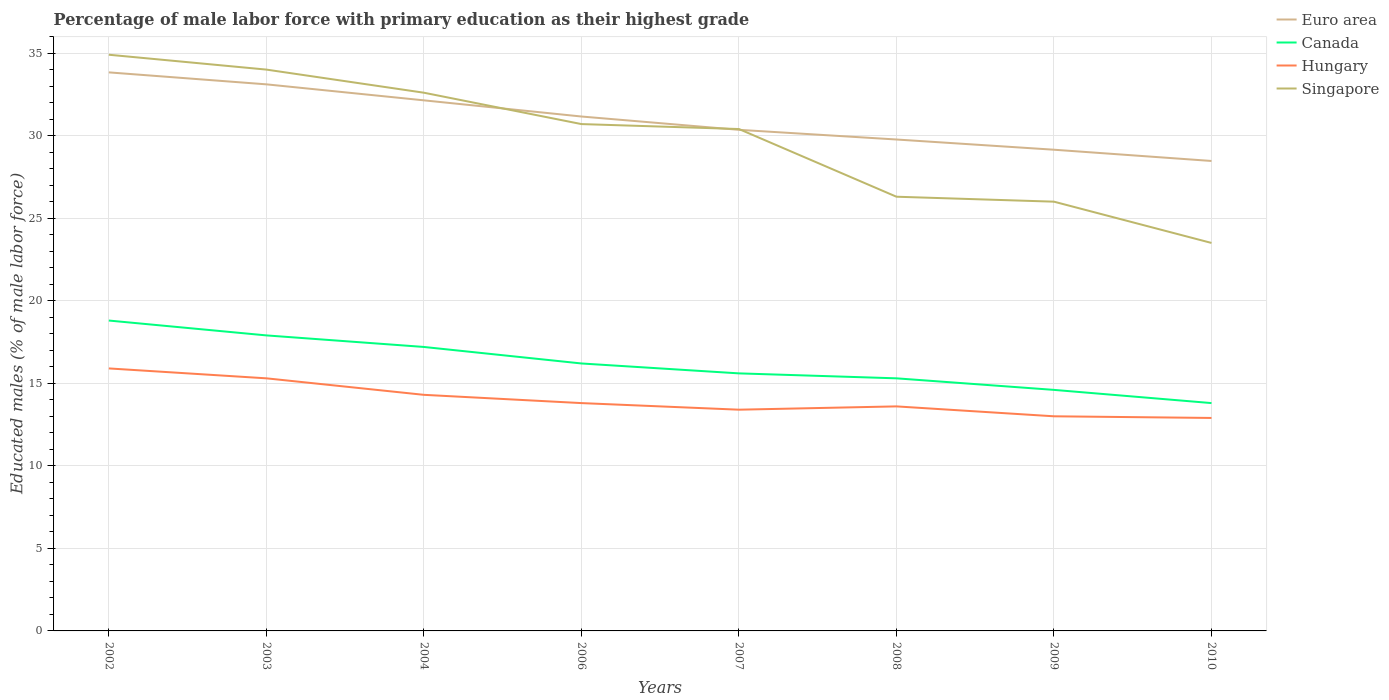Across all years, what is the maximum percentage of male labor force with primary education in Euro area?
Keep it short and to the point. 28.47. What is the total percentage of male labor force with primary education in Singapore in the graph?
Provide a succinct answer. 7.7. What is the difference between the highest and the second highest percentage of male labor force with primary education in Euro area?
Your answer should be compact. 5.37. Is the percentage of male labor force with primary education in Singapore strictly greater than the percentage of male labor force with primary education in Euro area over the years?
Offer a very short reply. No. How many lines are there?
Ensure brevity in your answer.  4. How many years are there in the graph?
Your answer should be compact. 8. What is the difference between two consecutive major ticks on the Y-axis?
Provide a short and direct response. 5. Does the graph contain any zero values?
Provide a short and direct response. No. Does the graph contain grids?
Your answer should be very brief. Yes. Where does the legend appear in the graph?
Offer a terse response. Top right. What is the title of the graph?
Your answer should be very brief. Percentage of male labor force with primary education as their highest grade. What is the label or title of the X-axis?
Provide a short and direct response. Years. What is the label or title of the Y-axis?
Provide a short and direct response. Educated males (% of male labor force). What is the Educated males (% of male labor force) of Euro area in 2002?
Provide a short and direct response. 33.83. What is the Educated males (% of male labor force) in Canada in 2002?
Your answer should be compact. 18.8. What is the Educated males (% of male labor force) in Hungary in 2002?
Make the answer very short. 15.9. What is the Educated males (% of male labor force) of Singapore in 2002?
Provide a short and direct response. 34.9. What is the Educated males (% of male labor force) of Euro area in 2003?
Make the answer very short. 33.11. What is the Educated males (% of male labor force) of Canada in 2003?
Ensure brevity in your answer.  17.9. What is the Educated males (% of male labor force) in Hungary in 2003?
Make the answer very short. 15.3. What is the Educated males (% of male labor force) in Singapore in 2003?
Ensure brevity in your answer.  34. What is the Educated males (% of male labor force) of Euro area in 2004?
Offer a very short reply. 32.14. What is the Educated males (% of male labor force) of Canada in 2004?
Provide a short and direct response. 17.2. What is the Educated males (% of male labor force) in Hungary in 2004?
Provide a short and direct response. 14.3. What is the Educated males (% of male labor force) of Singapore in 2004?
Ensure brevity in your answer.  32.6. What is the Educated males (% of male labor force) in Euro area in 2006?
Provide a succinct answer. 31.16. What is the Educated males (% of male labor force) in Canada in 2006?
Ensure brevity in your answer.  16.2. What is the Educated males (% of male labor force) in Hungary in 2006?
Your answer should be very brief. 13.8. What is the Educated males (% of male labor force) in Singapore in 2006?
Provide a short and direct response. 30.7. What is the Educated males (% of male labor force) of Euro area in 2007?
Provide a succinct answer. 30.35. What is the Educated males (% of male labor force) in Canada in 2007?
Offer a terse response. 15.6. What is the Educated males (% of male labor force) of Hungary in 2007?
Your answer should be compact. 13.4. What is the Educated males (% of male labor force) in Singapore in 2007?
Give a very brief answer. 30.4. What is the Educated males (% of male labor force) of Euro area in 2008?
Provide a short and direct response. 29.77. What is the Educated males (% of male labor force) of Canada in 2008?
Offer a very short reply. 15.3. What is the Educated males (% of male labor force) of Hungary in 2008?
Provide a short and direct response. 13.6. What is the Educated males (% of male labor force) of Singapore in 2008?
Ensure brevity in your answer.  26.3. What is the Educated males (% of male labor force) in Euro area in 2009?
Offer a terse response. 29.15. What is the Educated males (% of male labor force) in Canada in 2009?
Your response must be concise. 14.6. What is the Educated males (% of male labor force) of Hungary in 2009?
Make the answer very short. 13. What is the Educated males (% of male labor force) of Euro area in 2010?
Provide a short and direct response. 28.47. What is the Educated males (% of male labor force) in Canada in 2010?
Keep it short and to the point. 13.8. What is the Educated males (% of male labor force) of Hungary in 2010?
Your answer should be compact. 12.9. Across all years, what is the maximum Educated males (% of male labor force) of Euro area?
Keep it short and to the point. 33.83. Across all years, what is the maximum Educated males (% of male labor force) in Canada?
Ensure brevity in your answer.  18.8. Across all years, what is the maximum Educated males (% of male labor force) of Hungary?
Make the answer very short. 15.9. Across all years, what is the maximum Educated males (% of male labor force) of Singapore?
Keep it short and to the point. 34.9. Across all years, what is the minimum Educated males (% of male labor force) of Euro area?
Give a very brief answer. 28.47. Across all years, what is the minimum Educated males (% of male labor force) of Canada?
Keep it short and to the point. 13.8. Across all years, what is the minimum Educated males (% of male labor force) in Hungary?
Your answer should be compact. 12.9. Across all years, what is the minimum Educated males (% of male labor force) in Singapore?
Offer a terse response. 23.5. What is the total Educated males (% of male labor force) of Euro area in the graph?
Give a very brief answer. 247.96. What is the total Educated males (% of male labor force) of Canada in the graph?
Provide a short and direct response. 129.4. What is the total Educated males (% of male labor force) of Hungary in the graph?
Your response must be concise. 112.2. What is the total Educated males (% of male labor force) in Singapore in the graph?
Provide a succinct answer. 238.4. What is the difference between the Educated males (% of male labor force) of Euro area in 2002 and that in 2003?
Offer a very short reply. 0.72. What is the difference between the Educated males (% of male labor force) of Hungary in 2002 and that in 2003?
Make the answer very short. 0.6. What is the difference between the Educated males (% of male labor force) of Singapore in 2002 and that in 2003?
Make the answer very short. 0.9. What is the difference between the Educated males (% of male labor force) of Euro area in 2002 and that in 2004?
Ensure brevity in your answer.  1.69. What is the difference between the Educated males (% of male labor force) of Hungary in 2002 and that in 2004?
Your response must be concise. 1.6. What is the difference between the Educated males (% of male labor force) in Singapore in 2002 and that in 2004?
Your answer should be very brief. 2.3. What is the difference between the Educated males (% of male labor force) of Euro area in 2002 and that in 2006?
Your answer should be compact. 2.67. What is the difference between the Educated males (% of male labor force) in Canada in 2002 and that in 2006?
Your answer should be compact. 2.6. What is the difference between the Educated males (% of male labor force) of Hungary in 2002 and that in 2006?
Keep it short and to the point. 2.1. What is the difference between the Educated males (% of male labor force) of Euro area in 2002 and that in 2007?
Keep it short and to the point. 3.48. What is the difference between the Educated males (% of male labor force) of Hungary in 2002 and that in 2007?
Your answer should be compact. 2.5. What is the difference between the Educated males (% of male labor force) of Euro area in 2002 and that in 2008?
Keep it short and to the point. 4.07. What is the difference between the Educated males (% of male labor force) in Canada in 2002 and that in 2008?
Provide a succinct answer. 3.5. What is the difference between the Educated males (% of male labor force) in Hungary in 2002 and that in 2008?
Your response must be concise. 2.3. What is the difference between the Educated males (% of male labor force) of Euro area in 2002 and that in 2009?
Ensure brevity in your answer.  4.68. What is the difference between the Educated males (% of male labor force) of Canada in 2002 and that in 2009?
Offer a very short reply. 4.2. What is the difference between the Educated males (% of male labor force) of Singapore in 2002 and that in 2009?
Make the answer very short. 8.9. What is the difference between the Educated males (% of male labor force) of Euro area in 2002 and that in 2010?
Make the answer very short. 5.37. What is the difference between the Educated males (% of male labor force) of Hungary in 2002 and that in 2010?
Make the answer very short. 3. What is the difference between the Educated males (% of male labor force) in Singapore in 2002 and that in 2010?
Your answer should be compact. 11.4. What is the difference between the Educated males (% of male labor force) in Singapore in 2003 and that in 2004?
Provide a short and direct response. 1.4. What is the difference between the Educated males (% of male labor force) in Euro area in 2003 and that in 2006?
Your answer should be compact. 1.95. What is the difference between the Educated males (% of male labor force) in Singapore in 2003 and that in 2006?
Offer a terse response. 3.3. What is the difference between the Educated males (% of male labor force) of Euro area in 2003 and that in 2007?
Provide a succinct answer. 2.75. What is the difference between the Educated males (% of male labor force) in Canada in 2003 and that in 2007?
Keep it short and to the point. 2.3. What is the difference between the Educated males (% of male labor force) of Hungary in 2003 and that in 2007?
Offer a terse response. 1.9. What is the difference between the Educated males (% of male labor force) of Euro area in 2003 and that in 2008?
Keep it short and to the point. 3.34. What is the difference between the Educated males (% of male labor force) in Canada in 2003 and that in 2008?
Offer a very short reply. 2.6. What is the difference between the Educated males (% of male labor force) of Singapore in 2003 and that in 2008?
Offer a terse response. 7.7. What is the difference between the Educated males (% of male labor force) of Euro area in 2003 and that in 2009?
Provide a short and direct response. 3.96. What is the difference between the Educated males (% of male labor force) in Canada in 2003 and that in 2009?
Offer a terse response. 3.3. What is the difference between the Educated males (% of male labor force) of Hungary in 2003 and that in 2009?
Your response must be concise. 2.3. What is the difference between the Educated males (% of male labor force) of Euro area in 2003 and that in 2010?
Your answer should be very brief. 4.64. What is the difference between the Educated males (% of male labor force) in Canada in 2003 and that in 2010?
Give a very brief answer. 4.1. What is the difference between the Educated males (% of male labor force) in Hungary in 2003 and that in 2010?
Keep it short and to the point. 2.4. What is the difference between the Educated males (% of male labor force) in Euro area in 2004 and that in 2006?
Your response must be concise. 0.98. What is the difference between the Educated males (% of male labor force) in Canada in 2004 and that in 2006?
Keep it short and to the point. 1. What is the difference between the Educated males (% of male labor force) of Hungary in 2004 and that in 2006?
Your response must be concise. 0.5. What is the difference between the Educated males (% of male labor force) of Euro area in 2004 and that in 2007?
Provide a succinct answer. 1.79. What is the difference between the Educated males (% of male labor force) in Euro area in 2004 and that in 2008?
Provide a short and direct response. 2.37. What is the difference between the Educated males (% of male labor force) in Canada in 2004 and that in 2008?
Your response must be concise. 1.9. What is the difference between the Educated males (% of male labor force) of Singapore in 2004 and that in 2008?
Your response must be concise. 6.3. What is the difference between the Educated males (% of male labor force) of Euro area in 2004 and that in 2009?
Give a very brief answer. 2.99. What is the difference between the Educated males (% of male labor force) of Singapore in 2004 and that in 2009?
Your answer should be very brief. 6.6. What is the difference between the Educated males (% of male labor force) of Euro area in 2004 and that in 2010?
Give a very brief answer. 3.67. What is the difference between the Educated males (% of male labor force) of Canada in 2004 and that in 2010?
Provide a succinct answer. 3.4. What is the difference between the Educated males (% of male labor force) in Hungary in 2004 and that in 2010?
Provide a succinct answer. 1.4. What is the difference between the Educated males (% of male labor force) in Singapore in 2004 and that in 2010?
Keep it short and to the point. 9.1. What is the difference between the Educated males (% of male labor force) in Euro area in 2006 and that in 2007?
Offer a terse response. 0.81. What is the difference between the Educated males (% of male labor force) in Canada in 2006 and that in 2007?
Your answer should be compact. 0.6. What is the difference between the Educated males (% of male labor force) of Singapore in 2006 and that in 2007?
Offer a very short reply. 0.3. What is the difference between the Educated males (% of male labor force) of Euro area in 2006 and that in 2008?
Offer a terse response. 1.39. What is the difference between the Educated males (% of male labor force) in Hungary in 2006 and that in 2008?
Your answer should be very brief. 0.2. What is the difference between the Educated males (% of male labor force) in Singapore in 2006 and that in 2008?
Keep it short and to the point. 4.4. What is the difference between the Educated males (% of male labor force) of Euro area in 2006 and that in 2009?
Keep it short and to the point. 2.01. What is the difference between the Educated males (% of male labor force) of Hungary in 2006 and that in 2009?
Give a very brief answer. 0.8. What is the difference between the Educated males (% of male labor force) of Singapore in 2006 and that in 2009?
Your answer should be very brief. 4.7. What is the difference between the Educated males (% of male labor force) in Euro area in 2006 and that in 2010?
Keep it short and to the point. 2.69. What is the difference between the Educated males (% of male labor force) of Canada in 2006 and that in 2010?
Provide a short and direct response. 2.4. What is the difference between the Educated males (% of male labor force) of Euro area in 2007 and that in 2008?
Keep it short and to the point. 0.59. What is the difference between the Educated males (% of male labor force) in Canada in 2007 and that in 2008?
Give a very brief answer. 0.3. What is the difference between the Educated males (% of male labor force) in Hungary in 2007 and that in 2008?
Make the answer very short. -0.2. What is the difference between the Educated males (% of male labor force) of Singapore in 2007 and that in 2008?
Make the answer very short. 4.1. What is the difference between the Educated males (% of male labor force) in Euro area in 2007 and that in 2009?
Provide a succinct answer. 1.21. What is the difference between the Educated males (% of male labor force) in Canada in 2007 and that in 2009?
Provide a succinct answer. 1. What is the difference between the Educated males (% of male labor force) in Hungary in 2007 and that in 2009?
Your answer should be very brief. 0.4. What is the difference between the Educated males (% of male labor force) in Singapore in 2007 and that in 2009?
Offer a terse response. 4.4. What is the difference between the Educated males (% of male labor force) in Euro area in 2007 and that in 2010?
Your answer should be very brief. 1.89. What is the difference between the Educated males (% of male labor force) of Canada in 2007 and that in 2010?
Your response must be concise. 1.8. What is the difference between the Educated males (% of male labor force) of Hungary in 2007 and that in 2010?
Your answer should be very brief. 0.5. What is the difference between the Educated males (% of male labor force) in Singapore in 2007 and that in 2010?
Keep it short and to the point. 6.9. What is the difference between the Educated males (% of male labor force) in Euro area in 2008 and that in 2009?
Your answer should be compact. 0.62. What is the difference between the Educated males (% of male labor force) of Euro area in 2008 and that in 2010?
Keep it short and to the point. 1.3. What is the difference between the Educated males (% of male labor force) in Canada in 2008 and that in 2010?
Make the answer very short. 1.5. What is the difference between the Educated males (% of male labor force) in Euro area in 2009 and that in 2010?
Your answer should be compact. 0.68. What is the difference between the Educated males (% of male labor force) of Euro area in 2002 and the Educated males (% of male labor force) of Canada in 2003?
Make the answer very short. 15.93. What is the difference between the Educated males (% of male labor force) in Euro area in 2002 and the Educated males (% of male labor force) in Hungary in 2003?
Ensure brevity in your answer.  18.53. What is the difference between the Educated males (% of male labor force) of Euro area in 2002 and the Educated males (% of male labor force) of Singapore in 2003?
Offer a very short reply. -0.17. What is the difference between the Educated males (% of male labor force) in Canada in 2002 and the Educated males (% of male labor force) in Hungary in 2003?
Your response must be concise. 3.5. What is the difference between the Educated males (% of male labor force) in Canada in 2002 and the Educated males (% of male labor force) in Singapore in 2003?
Make the answer very short. -15.2. What is the difference between the Educated males (% of male labor force) in Hungary in 2002 and the Educated males (% of male labor force) in Singapore in 2003?
Your answer should be compact. -18.1. What is the difference between the Educated males (% of male labor force) of Euro area in 2002 and the Educated males (% of male labor force) of Canada in 2004?
Ensure brevity in your answer.  16.63. What is the difference between the Educated males (% of male labor force) of Euro area in 2002 and the Educated males (% of male labor force) of Hungary in 2004?
Your response must be concise. 19.53. What is the difference between the Educated males (% of male labor force) of Euro area in 2002 and the Educated males (% of male labor force) of Singapore in 2004?
Give a very brief answer. 1.23. What is the difference between the Educated males (% of male labor force) of Canada in 2002 and the Educated males (% of male labor force) of Hungary in 2004?
Your answer should be compact. 4.5. What is the difference between the Educated males (% of male labor force) of Canada in 2002 and the Educated males (% of male labor force) of Singapore in 2004?
Make the answer very short. -13.8. What is the difference between the Educated males (% of male labor force) of Hungary in 2002 and the Educated males (% of male labor force) of Singapore in 2004?
Keep it short and to the point. -16.7. What is the difference between the Educated males (% of male labor force) in Euro area in 2002 and the Educated males (% of male labor force) in Canada in 2006?
Offer a terse response. 17.63. What is the difference between the Educated males (% of male labor force) of Euro area in 2002 and the Educated males (% of male labor force) of Hungary in 2006?
Your answer should be compact. 20.03. What is the difference between the Educated males (% of male labor force) of Euro area in 2002 and the Educated males (% of male labor force) of Singapore in 2006?
Provide a short and direct response. 3.13. What is the difference between the Educated males (% of male labor force) in Hungary in 2002 and the Educated males (% of male labor force) in Singapore in 2006?
Offer a terse response. -14.8. What is the difference between the Educated males (% of male labor force) in Euro area in 2002 and the Educated males (% of male labor force) in Canada in 2007?
Make the answer very short. 18.23. What is the difference between the Educated males (% of male labor force) in Euro area in 2002 and the Educated males (% of male labor force) in Hungary in 2007?
Offer a terse response. 20.43. What is the difference between the Educated males (% of male labor force) of Euro area in 2002 and the Educated males (% of male labor force) of Singapore in 2007?
Ensure brevity in your answer.  3.43. What is the difference between the Educated males (% of male labor force) in Canada in 2002 and the Educated males (% of male labor force) in Singapore in 2007?
Your answer should be very brief. -11.6. What is the difference between the Educated males (% of male labor force) in Hungary in 2002 and the Educated males (% of male labor force) in Singapore in 2007?
Your answer should be compact. -14.5. What is the difference between the Educated males (% of male labor force) of Euro area in 2002 and the Educated males (% of male labor force) of Canada in 2008?
Your answer should be very brief. 18.53. What is the difference between the Educated males (% of male labor force) of Euro area in 2002 and the Educated males (% of male labor force) of Hungary in 2008?
Give a very brief answer. 20.23. What is the difference between the Educated males (% of male labor force) of Euro area in 2002 and the Educated males (% of male labor force) of Singapore in 2008?
Your answer should be very brief. 7.53. What is the difference between the Educated males (% of male labor force) of Canada in 2002 and the Educated males (% of male labor force) of Hungary in 2008?
Offer a very short reply. 5.2. What is the difference between the Educated males (% of male labor force) of Euro area in 2002 and the Educated males (% of male labor force) of Canada in 2009?
Your answer should be very brief. 19.23. What is the difference between the Educated males (% of male labor force) in Euro area in 2002 and the Educated males (% of male labor force) in Hungary in 2009?
Your response must be concise. 20.83. What is the difference between the Educated males (% of male labor force) of Euro area in 2002 and the Educated males (% of male labor force) of Singapore in 2009?
Your answer should be very brief. 7.83. What is the difference between the Educated males (% of male labor force) of Canada in 2002 and the Educated males (% of male labor force) of Singapore in 2009?
Your response must be concise. -7.2. What is the difference between the Educated males (% of male labor force) of Hungary in 2002 and the Educated males (% of male labor force) of Singapore in 2009?
Give a very brief answer. -10.1. What is the difference between the Educated males (% of male labor force) in Euro area in 2002 and the Educated males (% of male labor force) in Canada in 2010?
Provide a succinct answer. 20.03. What is the difference between the Educated males (% of male labor force) of Euro area in 2002 and the Educated males (% of male labor force) of Hungary in 2010?
Ensure brevity in your answer.  20.93. What is the difference between the Educated males (% of male labor force) in Euro area in 2002 and the Educated males (% of male labor force) in Singapore in 2010?
Keep it short and to the point. 10.33. What is the difference between the Educated males (% of male labor force) of Canada in 2002 and the Educated males (% of male labor force) of Singapore in 2010?
Your answer should be compact. -4.7. What is the difference between the Educated males (% of male labor force) in Euro area in 2003 and the Educated males (% of male labor force) in Canada in 2004?
Give a very brief answer. 15.91. What is the difference between the Educated males (% of male labor force) in Euro area in 2003 and the Educated males (% of male labor force) in Hungary in 2004?
Your response must be concise. 18.81. What is the difference between the Educated males (% of male labor force) in Euro area in 2003 and the Educated males (% of male labor force) in Singapore in 2004?
Make the answer very short. 0.51. What is the difference between the Educated males (% of male labor force) of Canada in 2003 and the Educated males (% of male labor force) of Singapore in 2004?
Keep it short and to the point. -14.7. What is the difference between the Educated males (% of male labor force) in Hungary in 2003 and the Educated males (% of male labor force) in Singapore in 2004?
Ensure brevity in your answer.  -17.3. What is the difference between the Educated males (% of male labor force) of Euro area in 2003 and the Educated males (% of male labor force) of Canada in 2006?
Offer a very short reply. 16.91. What is the difference between the Educated males (% of male labor force) in Euro area in 2003 and the Educated males (% of male labor force) in Hungary in 2006?
Your answer should be compact. 19.31. What is the difference between the Educated males (% of male labor force) of Euro area in 2003 and the Educated males (% of male labor force) of Singapore in 2006?
Give a very brief answer. 2.41. What is the difference between the Educated males (% of male labor force) in Canada in 2003 and the Educated males (% of male labor force) in Singapore in 2006?
Give a very brief answer. -12.8. What is the difference between the Educated males (% of male labor force) in Hungary in 2003 and the Educated males (% of male labor force) in Singapore in 2006?
Make the answer very short. -15.4. What is the difference between the Educated males (% of male labor force) in Euro area in 2003 and the Educated males (% of male labor force) in Canada in 2007?
Your response must be concise. 17.51. What is the difference between the Educated males (% of male labor force) of Euro area in 2003 and the Educated males (% of male labor force) of Hungary in 2007?
Keep it short and to the point. 19.71. What is the difference between the Educated males (% of male labor force) of Euro area in 2003 and the Educated males (% of male labor force) of Singapore in 2007?
Your response must be concise. 2.71. What is the difference between the Educated males (% of male labor force) in Canada in 2003 and the Educated males (% of male labor force) in Hungary in 2007?
Your response must be concise. 4.5. What is the difference between the Educated males (% of male labor force) in Canada in 2003 and the Educated males (% of male labor force) in Singapore in 2007?
Ensure brevity in your answer.  -12.5. What is the difference between the Educated males (% of male labor force) in Hungary in 2003 and the Educated males (% of male labor force) in Singapore in 2007?
Your answer should be very brief. -15.1. What is the difference between the Educated males (% of male labor force) in Euro area in 2003 and the Educated males (% of male labor force) in Canada in 2008?
Give a very brief answer. 17.81. What is the difference between the Educated males (% of male labor force) in Euro area in 2003 and the Educated males (% of male labor force) in Hungary in 2008?
Your answer should be very brief. 19.51. What is the difference between the Educated males (% of male labor force) of Euro area in 2003 and the Educated males (% of male labor force) of Singapore in 2008?
Offer a very short reply. 6.81. What is the difference between the Educated males (% of male labor force) of Canada in 2003 and the Educated males (% of male labor force) of Hungary in 2008?
Ensure brevity in your answer.  4.3. What is the difference between the Educated males (% of male labor force) in Canada in 2003 and the Educated males (% of male labor force) in Singapore in 2008?
Your answer should be very brief. -8.4. What is the difference between the Educated males (% of male labor force) of Euro area in 2003 and the Educated males (% of male labor force) of Canada in 2009?
Your answer should be compact. 18.51. What is the difference between the Educated males (% of male labor force) of Euro area in 2003 and the Educated males (% of male labor force) of Hungary in 2009?
Provide a short and direct response. 20.11. What is the difference between the Educated males (% of male labor force) of Euro area in 2003 and the Educated males (% of male labor force) of Singapore in 2009?
Keep it short and to the point. 7.11. What is the difference between the Educated males (% of male labor force) of Canada in 2003 and the Educated males (% of male labor force) of Hungary in 2009?
Keep it short and to the point. 4.9. What is the difference between the Educated males (% of male labor force) of Canada in 2003 and the Educated males (% of male labor force) of Singapore in 2009?
Ensure brevity in your answer.  -8.1. What is the difference between the Educated males (% of male labor force) of Hungary in 2003 and the Educated males (% of male labor force) of Singapore in 2009?
Your response must be concise. -10.7. What is the difference between the Educated males (% of male labor force) of Euro area in 2003 and the Educated males (% of male labor force) of Canada in 2010?
Keep it short and to the point. 19.31. What is the difference between the Educated males (% of male labor force) of Euro area in 2003 and the Educated males (% of male labor force) of Hungary in 2010?
Keep it short and to the point. 20.21. What is the difference between the Educated males (% of male labor force) of Euro area in 2003 and the Educated males (% of male labor force) of Singapore in 2010?
Make the answer very short. 9.61. What is the difference between the Educated males (% of male labor force) of Canada in 2003 and the Educated males (% of male labor force) of Hungary in 2010?
Offer a very short reply. 5. What is the difference between the Educated males (% of male labor force) in Canada in 2003 and the Educated males (% of male labor force) in Singapore in 2010?
Make the answer very short. -5.6. What is the difference between the Educated males (% of male labor force) in Euro area in 2004 and the Educated males (% of male labor force) in Canada in 2006?
Provide a succinct answer. 15.94. What is the difference between the Educated males (% of male labor force) in Euro area in 2004 and the Educated males (% of male labor force) in Hungary in 2006?
Make the answer very short. 18.34. What is the difference between the Educated males (% of male labor force) in Euro area in 2004 and the Educated males (% of male labor force) in Singapore in 2006?
Your response must be concise. 1.44. What is the difference between the Educated males (% of male labor force) of Canada in 2004 and the Educated males (% of male labor force) of Hungary in 2006?
Make the answer very short. 3.4. What is the difference between the Educated males (% of male labor force) of Canada in 2004 and the Educated males (% of male labor force) of Singapore in 2006?
Your answer should be very brief. -13.5. What is the difference between the Educated males (% of male labor force) in Hungary in 2004 and the Educated males (% of male labor force) in Singapore in 2006?
Provide a succinct answer. -16.4. What is the difference between the Educated males (% of male labor force) in Euro area in 2004 and the Educated males (% of male labor force) in Canada in 2007?
Keep it short and to the point. 16.54. What is the difference between the Educated males (% of male labor force) in Euro area in 2004 and the Educated males (% of male labor force) in Hungary in 2007?
Keep it short and to the point. 18.74. What is the difference between the Educated males (% of male labor force) in Euro area in 2004 and the Educated males (% of male labor force) in Singapore in 2007?
Keep it short and to the point. 1.74. What is the difference between the Educated males (% of male labor force) in Canada in 2004 and the Educated males (% of male labor force) in Hungary in 2007?
Provide a short and direct response. 3.8. What is the difference between the Educated males (% of male labor force) of Canada in 2004 and the Educated males (% of male labor force) of Singapore in 2007?
Provide a succinct answer. -13.2. What is the difference between the Educated males (% of male labor force) in Hungary in 2004 and the Educated males (% of male labor force) in Singapore in 2007?
Your answer should be very brief. -16.1. What is the difference between the Educated males (% of male labor force) in Euro area in 2004 and the Educated males (% of male labor force) in Canada in 2008?
Make the answer very short. 16.84. What is the difference between the Educated males (% of male labor force) in Euro area in 2004 and the Educated males (% of male labor force) in Hungary in 2008?
Keep it short and to the point. 18.54. What is the difference between the Educated males (% of male labor force) of Euro area in 2004 and the Educated males (% of male labor force) of Singapore in 2008?
Ensure brevity in your answer.  5.84. What is the difference between the Educated males (% of male labor force) of Canada in 2004 and the Educated males (% of male labor force) of Hungary in 2008?
Your response must be concise. 3.6. What is the difference between the Educated males (% of male labor force) of Hungary in 2004 and the Educated males (% of male labor force) of Singapore in 2008?
Offer a very short reply. -12. What is the difference between the Educated males (% of male labor force) in Euro area in 2004 and the Educated males (% of male labor force) in Canada in 2009?
Offer a terse response. 17.54. What is the difference between the Educated males (% of male labor force) of Euro area in 2004 and the Educated males (% of male labor force) of Hungary in 2009?
Your response must be concise. 19.14. What is the difference between the Educated males (% of male labor force) of Euro area in 2004 and the Educated males (% of male labor force) of Singapore in 2009?
Your answer should be very brief. 6.14. What is the difference between the Educated males (% of male labor force) of Canada in 2004 and the Educated males (% of male labor force) of Singapore in 2009?
Keep it short and to the point. -8.8. What is the difference between the Educated males (% of male labor force) of Euro area in 2004 and the Educated males (% of male labor force) of Canada in 2010?
Offer a terse response. 18.34. What is the difference between the Educated males (% of male labor force) in Euro area in 2004 and the Educated males (% of male labor force) in Hungary in 2010?
Your response must be concise. 19.24. What is the difference between the Educated males (% of male labor force) in Euro area in 2004 and the Educated males (% of male labor force) in Singapore in 2010?
Keep it short and to the point. 8.64. What is the difference between the Educated males (% of male labor force) in Hungary in 2004 and the Educated males (% of male labor force) in Singapore in 2010?
Your answer should be very brief. -9.2. What is the difference between the Educated males (% of male labor force) in Euro area in 2006 and the Educated males (% of male labor force) in Canada in 2007?
Keep it short and to the point. 15.56. What is the difference between the Educated males (% of male labor force) of Euro area in 2006 and the Educated males (% of male labor force) of Hungary in 2007?
Your answer should be very brief. 17.76. What is the difference between the Educated males (% of male labor force) of Euro area in 2006 and the Educated males (% of male labor force) of Singapore in 2007?
Offer a terse response. 0.76. What is the difference between the Educated males (% of male labor force) in Canada in 2006 and the Educated males (% of male labor force) in Hungary in 2007?
Provide a succinct answer. 2.8. What is the difference between the Educated males (% of male labor force) in Hungary in 2006 and the Educated males (% of male labor force) in Singapore in 2007?
Give a very brief answer. -16.6. What is the difference between the Educated males (% of male labor force) in Euro area in 2006 and the Educated males (% of male labor force) in Canada in 2008?
Provide a short and direct response. 15.86. What is the difference between the Educated males (% of male labor force) in Euro area in 2006 and the Educated males (% of male labor force) in Hungary in 2008?
Offer a very short reply. 17.56. What is the difference between the Educated males (% of male labor force) of Euro area in 2006 and the Educated males (% of male labor force) of Singapore in 2008?
Your answer should be compact. 4.86. What is the difference between the Educated males (% of male labor force) of Canada in 2006 and the Educated males (% of male labor force) of Hungary in 2008?
Your answer should be very brief. 2.6. What is the difference between the Educated males (% of male labor force) in Canada in 2006 and the Educated males (% of male labor force) in Singapore in 2008?
Make the answer very short. -10.1. What is the difference between the Educated males (% of male labor force) of Euro area in 2006 and the Educated males (% of male labor force) of Canada in 2009?
Your answer should be very brief. 16.56. What is the difference between the Educated males (% of male labor force) of Euro area in 2006 and the Educated males (% of male labor force) of Hungary in 2009?
Offer a terse response. 18.16. What is the difference between the Educated males (% of male labor force) of Euro area in 2006 and the Educated males (% of male labor force) of Singapore in 2009?
Provide a succinct answer. 5.16. What is the difference between the Educated males (% of male labor force) in Canada in 2006 and the Educated males (% of male labor force) in Hungary in 2009?
Ensure brevity in your answer.  3.2. What is the difference between the Educated males (% of male labor force) in Canada in 2006 and the Educated males (% of male labor force) in Singapore in 2009?
Make the answer very short. -9.8. What is the difference between the Educated males (% of male labor force) of Euro area in 2006 and the Educated males (% of male labor force) of Canada in 2010?
Your answer should be very brief. 17.36. What is the difference between the Educated males (% of male labor force) of Euro area in 2006 and the Educated males (% of male labor force) of Hungary in 2010?
Provide a succinct answer. 18.26. What is the difference between the Educated males (% of male labor force) in Euro area in 2006 and the Educated males (% of male labor force) in Singapore in 2010?
Make the answer very short. 7.66. What is the difference between the Educated males (% of male labor force) in Canada in 2006 and the Educated males (% of male labor force) in Hungary in 2010?
Provide a succinct answer. 3.3. What is the difference between the Educated males (% of male labor force) of Canada in 2006 and the Educated males (% of male labor force) of Singapore in 2010?
Provide a short and direct response. -7.3. What is the difference between the Educated males (% of male labor force) of Hungary in 2006 and the Educated males (% of male labor force) of Singapore in 2010?
Keep it short and to the point. -9.7. What is the difference between the Educated males (% of male labor force) in Euro area in 2007 and the Educated males (% of male labor force) in Canada in 2008?
Ensure brevity in your answer.  15.05. What is the difference between the Educated males (% of male labor force) of Euro area in 2007 and the Educated males (% of male labor force) of Hungary in 2008?
Ensure brevity in your answer.  16.75. What is the difference between the Educated males (% of male labor force) of Euro area in 2007 and the Educated males (% of male labor force) of Singapore in 2008?
Your answer should be compact. 4.05. What is the difference between the Educated males (% of male labor force) of Canada in 2007 and the Educated males (% of male labor force) of Hungary in 2008?
Provide a short and direct response. 2. What is the difference between the Educated males (% of male labor force) in Canada in 2007 and the Educated males (% of male labor force) in Singapore in 2008?
Ensure brevity in your answer.  -10.7. What is the difference between the Educated males (% of male labor force) in Hungary in 2007 and the Educated males (% of male labor force) in Singapore in 2008?
Keep it short and to the point. -12.9. What is the difference between the Educated males (% of male labor force) in Euro area in 2007 and the Educated males (% of male labor force) in Canada in 2009?
Your answer should be very brief. 15.75. What is the difference between the Educated males (% of male labor force) of Euro area in 2007 and the Educated males (% of male labor force) of Hungary in 2009?
Keep it short and to the point. 17.35. What is the difference between the Educated males (% of male labor force) in Euro area in 2007 and the Educated males (% of male labor force) in Singapore in 2009?
Provide a succinct answer. 4.35. What is the difference between the Educated males (% of male labor force) of Euro area in 2007 and the Educated males (% of male labor force) of Canada in 2010?
Provide a succinct answer. 16.55. What is the difference between the Educated males (% of male labor force) of Euro area in 2007 and the Educated males (% of male labor force) of Hungary in 2010?
Provide a succinct answer. 17.45. What is the difference between the Educated males (% of male labor force) of Euro area in 2007 and the Educated males (% of male labor force) of Singapore in 2010?
Ensure brevity in your answer.  6.85. What is the difference between the Educated males (% of male labor force) in Canada in 2007 and the Educated males (% of male labor force) in Hungary in 2010?
Your response must be concise. 2.7. What is the difference between the Educated males (% of male labor force) of Hungary in 2007 and the Educated males (% of male labor force) of Singapore in 2010?
Offer a terse response. -10.1. What is the difference between the Educated males (% of male labor force) in Euro area in 2008 and the Educated males (% of male labor force) in Canada in 2009?
Ensure brevity in your answer.  15.17. What is the difference between the Educated males (% of male labor force) of Euro area in 2008 and the Educated males (% of male labor force) of Hungary in 2009?
Ensure brevity in your answer.  16.77. What is the difference between the Educated males (% of male labor force) of Euro area in 2008 and the Educated males (% of male labor force) of Singapore in 2009?
Ensure brevity in your answer.  3.77. What is the difference between the Educated males (% of male labor force) in Euro area in 2008 and the Educated males (% of male labor force) in Canada in 2010?
Offer a terse response. 15.97. What is the difference between the Educated males (% of male labor force) of Euro area in 2008 and the Educated males (% of male labor force) of Hungary in 2010?
Provide a short and direct response. 16.87. What is the difference between the Educated males (% of male labor force) in Euro area in 2008 and the Educated males (% of male labor force) in Singapore in 2010?
Make the answer very short. 6.27. What is the difference between the Educated males (% of male labor force) of Canada in 2008 and the Educated males (% of male labor force) of Hungary in 2010?
Offer a terse response. 2.4. What is the difference between the Educated males (% of male labor force) in Euro area in 2009 and the Educated males (% of male labor force) in Canada in 2010?
Provide a short and direct response. 15.35. What is the difference between the Educated males (% of male labor force) of Euro area in 2009 and the Educated males (% of male labor force) of Hungary in 2010?
Offer a terse response. 16.25. What is the difference between the Educated males (% of male labor force) in Euro area in 2009 and the Educated males (% of male labor force) in Singapore in 2010?
Your response must be concise. 5.65. What is the difference between the Educated males (% of male labor force) of Canada in 2009 and the Educated males (% of male labor force) of Hungary in 2010?
Give a very brief answer. 1.7. What is the average Educated males (% of male labor force) of Euro area per year?
Your response must be concise. 31. What is the average Educated males (% of male labor force) of Canada per year?
Offer a very short reply. 16.18. What is the average Educated males (% of male labor force) of Hungary per year?
Your response must be concise. 14.03. What is the average Educated males (% of male labor force) in Singapore per year?
Your answer should be compact. 29.8. In the year 2002, what is the difference between the Educated males (% of male labor force) in Euro area and Educated males (% of male labor force) in Canada?
Provide a short and direct response. 15.03. In the year 2002, what is the difference between the Educated males (% of male labor force) in Euro area and Educated males (% of male labor force) in Hungary?
Provide a succinct answer. 17.93. In the year 2002, what is the difference between the Educated males (% of male labor force) in Euro area and Educated males (% of male labor force) in Singapore?
Offer a terse response. -1.07. In the year 2002, what is the difference between the Educated males (% of male labor force) in Canada and Educated males (% of male labor force) in Hungary?
Your answer should be very brief. 2.9. In the year 2002, what is the difference between the Educated males (% of male labor force) of Canada and Educated males (% of male labor force) of Singapore?
Ensure brevity in your answer.  -16.1. In the year 2002, what is the difference between the Educated males (% of male labor force) in Hungary and Educated males (% of male labor force) in Singapore?
Your answer should be compact. -19. In the year 2003, what is the difference between the Educated males (% of male labor force) in Euro area and Educated males (% of male labor force) in Canada?
Your response must be concise. 15.21. In the year 2003, what is the difference between the Educated males (% of male labor force) of Euro area and Educated males (% of male labor force) of Hungary?
Offer a terse response. 17.81. In the year 2003, what is the difference between the Educated males (% of male labor force) of Euro area and Educated males (% of male labor force) of Singapore?
Give a very brief answer. -0.89. In the year 2003, what is the difference between the Educated males (% of male labor force) in Canada and Educated males (% of male labor force) in Singapore?
Ensure brevity in your answer.  -16.1. In the year 2003, what is the difference between the Educated males (% of male labor force) of Hungary and Educated males (% of male labor force) of Singapore?
Offer a terse response. -18.7. In the year 2004, what is the difference between the Educated males (% of male labor force) in Euro area and Educated males (% of male labor force) in Canada?
Ensure brevity in your answer.  14.94. In the year 2004, what is the difference between the Educated males (% of male labor force) of Euro area and Educated males (% of male labor force) of Hungary?
Your answer should be compact. 17.84. In the year 2004, what is the difference between the Educated males (% of male labor force) in Euro area and Educated males (% of male labor force) in Singapore?
Give a very brief answer. -0.46. In the year 2004, what is the difference between the Educated males (% of male labor force) of Canada and Educated males (% of male labor force) of Singapore?
Your answer should be very brief. -15.4. In the year 2004, what is the difference between the Educated males (% of male labor force) in Hungary and Educated males (% of male labor force) in Singapore?
Offer a very short reply. -18.3. In the year 2006, what is the difference between the Educated males (% of male labor force) of Euro area and Educated males (% of male labor force) of Canada?
Ensure brevity in your answer.  14.96. In the year 2006, what is the difference between the Educated males (% of male labor force) of Euro area and Educated males (% of male labor force) of Hungary?
Offer a very short reply. 17.36. In the year 2006, what is the difference between the Educated males (% of male labor force) of Euro area and Educated males (% of male labor force) of Singapore?
Ensure brevity in your answer.  0.46. In the year 2006, what is the difference between the Educated males (% of male labor force) of Hungary and Educated males (% of male labor force) of Singapore?
Provide a succinct answer. -16.9. In the year 2007, what is the difference between the Educated males (% of male labor force) in Euro area and Educated males (% of male labor force) in Canada?
Ensure brevity in your answer.  14.75. In the year 2007, what is the difference between the Educated males (% of male labor force) of Euro area and Educated males (% of male labor force) of Hungary?
Your answer should be compact. 16.95. In the year 2007, what is the difference between the Educated males (% of male labor force) of Euro area and Educated males (% of male labor force) of Singapore?
Make the answer very short. -0.05. In the year 2007, what is the difference between the Educated males (% of male labor force) in Canada and Educated males (% of male labor force) in Hungary?
Provide a short and direct response. 2.2. In the year 2007, what is the difference between the Educated males (% of male labor force) of Canada and Educated males (% of male labor force) of Singapore?
Make the answer very short. -14.8. In the year 2007, what is the difference between the Educated males (% of male labor force) in Hungary and Educated males (% of male labor force) in Singapore?
Your answer should be compact. -17. In the year 2008, what is the difference between the Educated males (% of male labor force) in Euro area and Educated males (% of male labor force) in Canada?
Your answer should be compact. 14.47. In the year 2008, what is the difference between the Educated males (% of male labor force) in Euro area and Educated males (% of male labor force) in Hungary?
Provide a succinct answer. 16.17. In the year 2008, what is the difference between the Educated males (% of male labor force) in Euro area and Educated males (% of male labor force) in Singapore?
Your answer should be very brief. 3.47. In the year 2008, what is the difference between the Educated males (% of male labor force) of Canada and Educated males (% of male labor force) of Hungary?
Make the answer very short. 1.7. In the year 2008, what is the difference between the Educated males (% of male labor force) in Hungary and Educated males (% of male labor force) in Singapore?
Provide a succinct answer. -12.7. In the year 2009, what is the difference between the Educated males (% of male labor force) of Euro area and Educated males (% of male labor force) of Canada?
Provide a short and direct response. 14.55. In the year 2009, what is the difference between the Educated males (% of male labor force) of Euro area and Educated males (% of male labor force) of Hungary?
Provide a succinct answer. 16.15. In the year 2009, what is the difference between the Educated males (% of male labor force) in Euro area and Educated males (% of male labor force) in Singapore?
Provide a short and direct response. 3.15. In the year 2009, what is the difference between the Educated males (% of male labor force) of Canada and Educated males (% of male labor force) of Singapore?
Keep it short and to the point. -11.4. In the year 2010, what is the difference between the Educated males (% of male labor force) of Euro area and Educated males (% of male labor force) of Canada?
Give a very brief answer. 14.67. In the year 2010, what is the difference between the Educated males (% of male labor force) of Euro area and Educated males (% of male labor force) of Hungary?
Provide a short and direct response. 15.57. In the year 2010, what is the difference between the Educated males (% of male labor force) in Euro area and Educated males (% of male labor force) in Singapore?
Your answer should be very brief. 4.97. In the year 2010, what is the difference between the Educated males (% of male labor force) of Canada and Educated males (% of male labor force) of Hungary?
Offer a very short reply. 0.9. In the year 2010, what is the difference between the Educated males (% of male labor force) in Hungary and Educated males (% of male labor force) in Singapore?
Your answer should be very brief. -10.6. What is the ratio of the Educated males (% of male labor force) of Euro area in 2002 to that in 2003?
Offer a terse response. 1.02. What is the ratio of the Educated males (% of male labor force) of Canada in 2002 to that in 2003?
Your answer should be very brief. 1.05. What is the ratio of the Educated males (% of male labor force) in Hungary in 2002 to that in 2003?
Your answer should be compact. 1.04. What is the ratio of the Educated males (% of male labor force) in Singapore in 2002 to that in 2003?
Offer a very short reply. 1.03. What is the ratio of the Educated males (% of male labor force) in Euro area in 2002 to that in 2004?
Give a very brief answer. 1.05. What is the ratio of the Educated males (% of male labor force) in Canada in 2002 to that in 2004?
Provide a succinct answer. 1.09. What is the ratio of the Educated males (% of male labor force) of Hungary in 2002 to that in 2004?
Your response must be concise. 1.11. What is the ratio of the Educated males (% of male labor force) in Singapore in 2002 to that in 2004?
Keep it short and to the point. 1.07. What is the ratio of the Educated males (% of male labor force) in Euro area in 2002 to that in 2006?
Offer a very short reply. 1.09. What is the ratio of the Educated males (% of male labor force) of Canada in 2002 to that in 2006?
Provide a succinct answer. 1.16. What is the ratio of the Educated males (% of male labor force) in Hungary in 2002 to that in 2006?
Your answer should be compact. 1.15. What is the ratio of the Educated males (% of male labor force) of Singapore in 2002 to that in 2006?
Ensure brevity in your answer.  1.14. What is the ratio of the Educated males (% of male labor force) of Euro area in 2002 to that in 2007?
Keep it short and to the point. 1.11. What is the ratio of the Educated males (% of male labor force) of Canada in 2002 to that in 2007?
Your answer should be compact. 1.21. What is the ratio of the Educated males (% of male labor force) of Hungary in 2002 to that in 2007?
Give a very brief answer. 1.19. What is the ratio of the Educated males (% of male labor force) of Singapore in 2002 to that in 2007?
Provide a succinct answer. 1.15. What is the ratio of the Educated males (% of male labor force) in Euro area in 2002 to that in 2008?
Your answer should be compact. 1.14. What is the ratio of the Educated males (% of male labor force) of Canada in 2002 to that in 2008?
Offer a terse response. 1.23. What is the ratio of the Educated males (% of male labor force) of Hungary in 2002 to that in 2008?
Offer a very short reply. 1.17. What is the ratio of the Educated males (% of male labor force) in Singapore in 2002 to that in 2008?
Your answer should be compact. 1.33. What is the ratio of the Educated males (% of male labor force) in Euro area in 2002 to that in 2009?
Ensure brevity in your answer.  1.16. What is the ratio of the Educated males (% of male labor force) of Canada in 2002 to that in 2009?
Provide a short and direct response. 1.29. What is the ratio of the Educated males (% of male labor force) in Hungary in 2002 to that in 2009?
Your response must be concise. 1.22. What is the ratio of the Educated males (% of male labor force) in Singapore in 2002 to that in 2009?
Ensure brevity in your answer.  1.34. What is the ratio of the Educated males (% of male labor force) in Euro area in 2002 to that in 2010?
Offer a terse response. 1.19. What is the ratio of the Educated males (% of male labor force) in Canada in 2002 to that in 2010?
Provide a short and direct response. 1.36. What is the ratio of the Educated males (% of male labor force) of Hungary in 2002 to that in 2010?
Offer a very short reply. 1.23. What is the ratio of the Educated males (% of male labor force) in Singapore in 2002 to that in 2010?
Give a very brief answer. 1.49. What is the ratio of the Educated males (% of male labor force) in Euro area in 2003 to that in 2004?
Your answer should be very brief. 1.03. What is the ratio of the Educated males (% of male labor force) of Canada in 2003 to that in 2004?
Give a very brief answer. 1.04. What is the ratio of the Educated males (% of male labor force) of Hungary in 2003 to that in 2004?
Keep it short and to the point. 1.07. What is the ratio of the Educated males (% of male labor force) in Singapore in 2003 to that in 2004?
Your response must be concise. 1.04. What is the ratio of the Educated males (% of male labor force) of Euro area in 2003 to that in 2006?
Your response must be concise. 1.06. What is the ratio of the Educated males (% of male labor force) in Canada in 2003 to that in 2006?
Your answer should be very brief. 1.1. What is the ratio of the Educated males (% of male labor force) of Hungary in 2003 to that in 2006?
Give a very brief answer. 1.11. What is the ratio of the Educated males (% of male labor force) in Singapore in 2003 to that in 2006?
Provide a succinct answer. 1.11. What is the ratio of the Educated males (% of male labor force) of Euro area in 2003 to that in 2007?
Your response must be concise. 1.09. What is the ratio of the Educated males (% of male labor force) in Canada in 2003 to that in 2007?
Keep it short and to the point. 1.15. What is the ratio of the Educated males (% of male labor force) of Hungary in 2003 to that in 2007?
Your answer should be very brief. 1.14. What is the ratio of the Educated males (% of male labor force) in Singapore in 2003 to that in 2007?
Offer a very short reply. 1.12. What is the ratio of the Educated males (% of male labor force) in Euro area in 2003 to that in 2008?
Ensure brevity in your answer.  1.11. What is the ratio of the Educated males (% of male labor force) in Canada in 2003 to that in 2008?
Keep it short and to the point. 1.17. What is the ratio of the Educated males (% of male labor force) of Singapore in 2003 to that in 2008?
Your answer should be compact. 1.29. What is the ratio of the Educated males (% of male labor force) of Euro area in 2003 to that in 2009?
Your answer should be compact. 1.14. What is the ratio of the Educated males (% of male labor force) of Canada in 2003 to that in 2009?
Offer a terse response. 1.23. What is the ratio of the Educated males (% of male labor force) of Hungary in 2003 to that in 2009?
Offer a terse response. 1.18. What is the ratio of the Educated males (% of male labor force) in Singapore in 2003 to that in 2009?
Your response must be concise. 1.31. What is the ratio of the Educated males (% of male labor force) of Euro area in 2003 to that in 2010?
Offer a terse response. 1.16. What is the ratio of the Educated males (% of male labor force) in Canada in 2003 to that in 2010?
Offer a terse response. 1.3. What is the ratio of the Educated males (% of male labor force) in Hungary in 2003 to that in 2010?
Ensure brevity in your answer.  1.19. What is the ratio of the Educated males (% of male labor force) of Singapore in 2003 to that in 2010?
Provide a short and direct response. 1.45. What is the ratio of the Educated males (% of male labor force) of Euro area in 2004 to that in 2006?
Provide a short and direct response. 1.03. What is the ratio of the Educated males (% of male labor force) of Canada in 2004 to that in 2006?
Ensure brevity in your answer.  1.06. What is the ratio of the Educated males (% of male labor force) in Hungary in 2004 to that in 2006?
Your answer should be very brief. 1.04. What is the ratio of the Educated males (% of male labor force) in Singapore in 2004 to that in 2006?
Your answer should be very brief. 1.06. What is the ratio of the Educated males (% of male labor force) of Euro area in 2004 to that in 2007?
Your response must be concise. 1.06. What is the ratio of the Educated males (% of male labor force) in Canada in 2004 to that in 2007?
Keep it short and to the point. 1.1. What is the ratio of the Educated males (% of male labor force) in Hungary in 2004 to that in 2007?
Keep it short and to the point. 1.07. What is the ratio of the Educated males (% of male labor force) of Singapore in 2004 to that in 2007?
Your response must be concise. 1.07. What is the ratio of the Educated males (% of male labor force) in Euro area in 2004 to that in 2008?
Your answer should be very brief. 1.08. What is the ratio of the Educated males (% of male labor force) in Canada in 2004 to that in 2008?
Give a very brief answer. 1.12. What is the ratio of the Educated males (% of male labor force) of Hungary in 2004 to that in 2008?
Ensure brevity in your answer.  1.05. What is the ratio of the Educated males (% of male labor force) of Singapore in 2004 to that in 2008?
Offer a terse response. 1.24. What is the ratio of the Educated males (% of male labor force) of Euro area in 2004 to that in 2009?
Offer a terse response. 1.1. What is the ratio of the Educated males (% of male labor force) in Canada in 2004 to that in 2009?
Provide a succinct answer. 1.18. What is the ratio of the Educated males (% of male labor force) in Singapore in 2004 to that in 2009?
Ensure brevity in your answer.  1.25. What is the ratio of the Educated males (% of male labor force) in Euro area in 2004 to that in 2010?
Offer a very short reply. 1.13. What is the ratio of the Educated males (% of male labor force) in Canada in 2004 to that in 2010?
Make the answer very short. 1.25. What is the ratio of the Educated males (% of male labor force) of Hungary in 2004 to that in 2010?
Provide a succinct answer. 1.11. What is the ratio of the Educated males (% of male labor force) of Singapore in 2004 to that in 2010?
Make the answer very short. 1.39. What is the ratio of the Educated males (% of male labor force) of Euro area in 2006 to that in 2007?
Give a very brief answer. 1.03. What is the ratio of the Educated males (% of male labor force) of Canada in 2006 to that in 2007?
Keep it short and to the point. 1.04. What is the ratio of the Educated males (% of male labor force) in Hungary in 2006 to that in 2007?
Provide a short and direct response. 1.03. What is the ratio of the Educated males (% of male labor force) of Singapore in 2006 to that in 2007?
Offer a very short reply. 1.01. What is the ratio of the Educated males (% of male labor force) of Euro area in 2006 to that in 2008?
Ensure brevity in your answer.  1.05. What is the ratio of the Educated males (% of male labor force) of Canada in 2006 to that in 2008?
Give a very brief answer. 1.06. What is the ratio of the Educated males (% of male labor force) in Hungary in 2006 to that in 2008?
Make the answer very short. 1.01. What is the ratio of the Educated males (% of male labor force) in Singapore in 2006 to that in 2008?
Your answer should be very brief. 1.17. What is the ratio of the Educated males (% of male labor force) in Euro area in 2006 to that in 2009?
Your answer should be compact. 1.07. What is the ratio of the Educated males (% of male labor force) in Canada in 2006 to that in 2009?
Your response must be concise. 1.11. What is the ratio of the Educated males (% of male labor force) of Hungary in 2006 to that in 2009?
Your response must be concise. 1.06. What is the ratio of the Educated males (% of male labor force) of Singapore in 2006 to that in 2009?
Offer a terse response. 1.18. What is the ratio of the Educated males (% of male labor force) in Euro area in 2006 to that in 2010?
Ensure brevity in your answer.  1.09. What is the ratio of the Educated males (% of male labor force) of Canada in 2006 to that in 2010?
Offer a terse response. 1.17. What is the ratio of the Educated males (% of male labor force) of Hungary in 2006 to that in 2010?
Your answer should be very brief. 1.07. What is the ratio of the Educated males (% of male labor force) of Singapore in 2006 to that in 2010?
Ensure brevity in your answer.  1.31. What is the ratio of the Educated males (% of male labor force) in Euro area in 2007 to that in 2008?
Give a very brief answer. 1.02. What is the ratio of the Educated males (% of male labor force) of Canada in 2007 to that in 2008?
Give a very brief answer. 1.02. What is the ratio of the Educated males (% of male labor force) in Hungary in 2007 to that in 2008?
Offer a very short reply. 0.99. What is the ratio of the Educated males (% of male labor force) of Singapore in 2007 to that in 2008?
Make the answer very short. 1.16. What is the ratio of the Educated males (% of male labor force) in Euro area in 2007 to that in 2009?
Your answer should be compact. 1.04. What is the ratio of the Educated males (% of male labor force) of Canada in 2007 to that in 2009?
Offer a terse response. 1.07. What is the ratio of the Educated males (% of male labor force) of Hungary in 2007 to that in 2009?
Offer a very short reply. 1.03. What is the ratio of the Educated males (% of male labor force) of Singapore in 2007 to that in 2009?
Ensure brevity in your answer.  1.17. What is the ratio of the Educated males (% of male labor force) of Euro area in 2007 to that in 2010?
Make the answer very short. 1.07. What is the ratio of the Educated males (% of male labor force) of Canada in 2007 to that in 2010?
Provide a short and direct response. 1.13. What is the ratio of the Educated males (% of male labor force) of Hungary in 2007 to that in 2010?
Provide a short and direct response. 1.04. What is the ratio of the Educated males (% of male labor force) of Singapore in 2007 to that in 2010?
Offer a very short reply. 1.29. What is the ratio of the Educated males (% of male labor force) of Euro area in 2008 to that in 2009?
Your answer should be very brief. 1.02. What is the ratio of the Educated males (% of male labor force) in Canada in 2008 to that in 2009?
Give a very brief answer. 1.05. What is the ratio of the Educated males (% of male labor force) of Hungary in 2008 to that in 2009?
Make the answer very short. 1.05. What is the ratio of the Educated males (% of male labor force) of Singapore in 2008 to that in 2009?
Give a very brief answer. 1.01. What is the ratio of the Educated males (% of male labor force) in Euro area in 2008 to that in 2010?
Offer a very short reply. 1.05. What is the ratio of the Educated males (% of male labor force) in Canada in 2008 to that in 2010?
Provide a short and direct response. 1.11. What is the ratio of the Educated males (% of male labor force) in Hungary in 2008 to that in 2010?
Provide a short and direct response. 1.05. What is the ratio of the Educated males (% of male labor force) in Singapore in 2008 to that in 2010?
Ensure brevity in your answer.  1.12. What is the ratio of the Educated males (% of male labor force) in Euro area in 2009 to that in 2010?
Offer a very short reply. 1.02. What is the ratio of the Educated males (% of male labor force) in Canada in 2009 to that in 2010?
Keep it short and to the point. 1.06. What is the ratio of the Educated males (% of male labor force) of Singapore in 2009 to that in 2010?
Provide a succinct answer. 1.11. What is the difference between the highest and the second highest Educated males (% of male labor force) in Euro area?
Keep it short and to the point. 0.72. What is the difference between the highest and the second highest Educated males (% of male labor force) in Singapore?
Your answer should be compact. 0.9. What is the difference between the highest and the lowest Educated males (% of male labor force) in Euro area?
Offer a terse response. 5.37. 